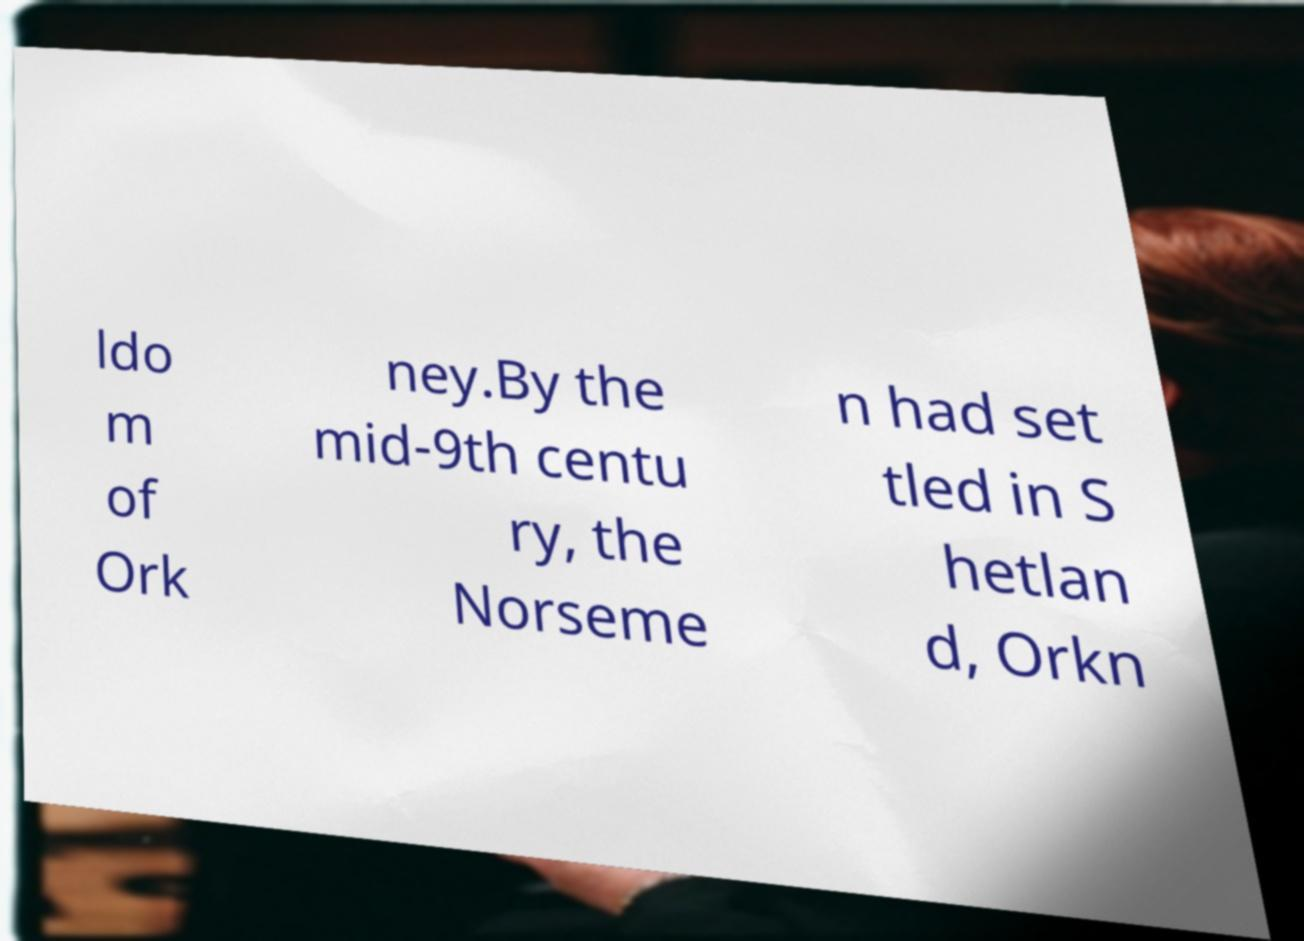Can you read and provide the text displayed in the image?This photo seems to have some interesting text. Can you extract and type it out for me? ldo m of Ork ney.By the mid-9th centu ry, the Norseme n had set tled in S hetlan d, Orkn 